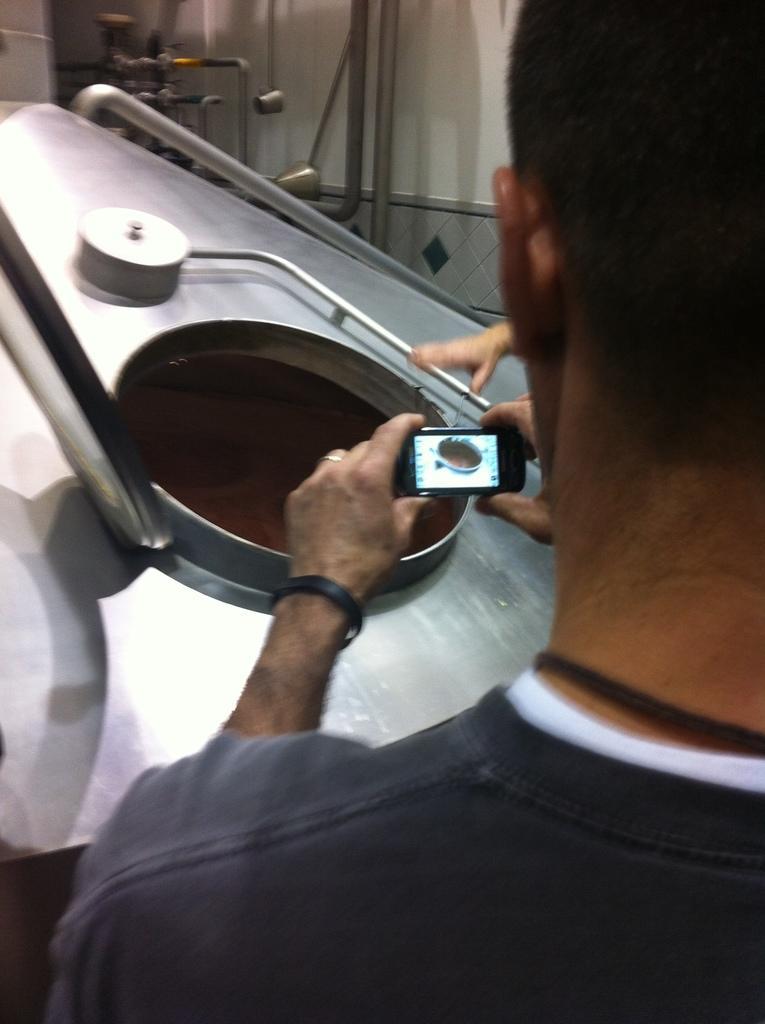Please provide a concise description of this image. There is a man holding mobile phone in front of dome. 